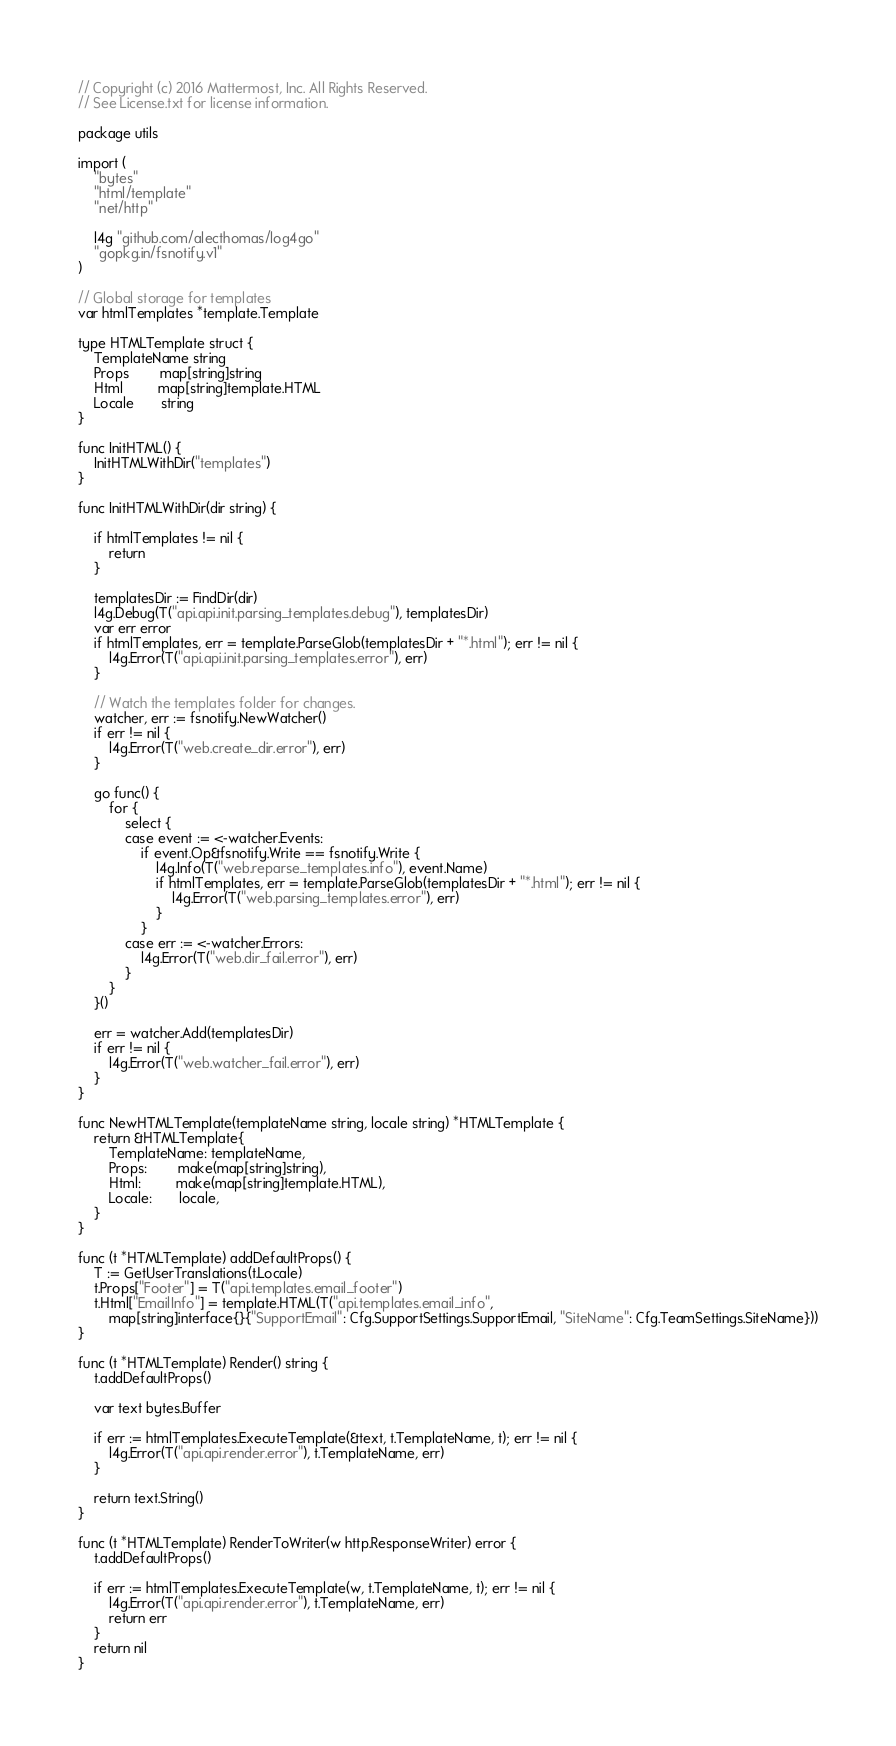<code> <loc_0><loc_0><loc_500><loc_500><_Go_>// Copyright (c) 2016 Mattermost, Inc. All Rights Reserved.
// See License.txt for license information.

package utils

import (
	"bytes"
	"html/template"
	"net/http"

	l4g "github.com/alecthomas/log4go"
	"gopkg.in/fsnotify.v1"
)

// Global storage for templates
var htmlTemplates *template.Template

type HTMLTemplate struct {
	TemplateName string
	Props        map[string]string
	Html         map[string]template.HTML
	Locale       string
}

func InitHTML() {
	InitHTMLWithDir("templates")
}

func InitHTMLWithDir(dir string) {

	if htmlTemplates != nil {
		return
	}

	templatesDir := FindDir(dir)
	l4g.Debug(T("api.api.init.parsing_templates.debug"), templatesDir)
	var err error
	if htmlTemplates, err = template.ParseGlob(templatesDir + "*.html"); err != nil {
		l4g.Error(T("api.api.init.parsing_templates.error"), err)
	}

	// Watch the templates folder for changes.
	watcher, err := fsnotify.NewWatcher()
	if err != nil {
		l4g.Error(T("web.create_dir.error"), err)
	}

	go func() {
		for {
			select {
			case event := <-watcher.Events:
				if event.Op&fsnotify.Write == fsnotify.Write {
					l4g.Info(T("web.reparse_templates.info"), event.Name)
					if htmlTemplates, err = template.ParseGlob(templatesDir + "*.html"); err != nil {
						l4g.Error(T("web.parsing_templates.error"), err)
					}
				}
			case err := <-watcher.Errors:
				l4g.Error(T("web.dir_fail.error"), err)
			}
		}
	}()

	err = watcher.Add(templatesDir)
	if err != nil {
		l4g.Error(T("web.watcher_fail.error"), err)
	}
}

func NewHTMLTemplate(templateName string, locale string) *HTMLTemplate {
	return &HTMLTemplate{
		TemplateName: templateName,
		Props:        make(map[string]string),
		Html:         make(map[string]template.HTML),
		Locale:       locale,
	}
}

func (t *HTMLTemplate) addDefaultProps() {
	T := GetUserTranslations(t.Locale)
	t.Props["Footer"] = T("api.templates.email_footer")
	t.Html["EmailInfo"] = template.HTML(T("api.templates.email_info",
		map[string]interface{}{"SupportEmail": Cfg.SupportSettings.SupportEmail, "SiteName": Cfg.TeamSettings.SiteName}))
}

func (t *HTMLTemplate) Render() string {
	t.addDefaultProps()

	var text bytes.Buffer

	if err := htmlTemplates.ExecuteTemplate(&text, t.TemplateName, t); err != nil {
		l4g.Error(T("api.api.render.error"), t.TemplateName, err)
	}

	return text.String()
}

func (t *HTMLTemplate) RenderToWriter(w http.ResponseWriter) error {
	t.addDefaultProps()

	if err := htmlTemplates.ExecuteTemplate(w, t.TemplateName, t); err != nil {
		l4g.Error(T("api.api.render.error"), t.TemplateName, err)
		return err
	}
	return nil
}
</code> 